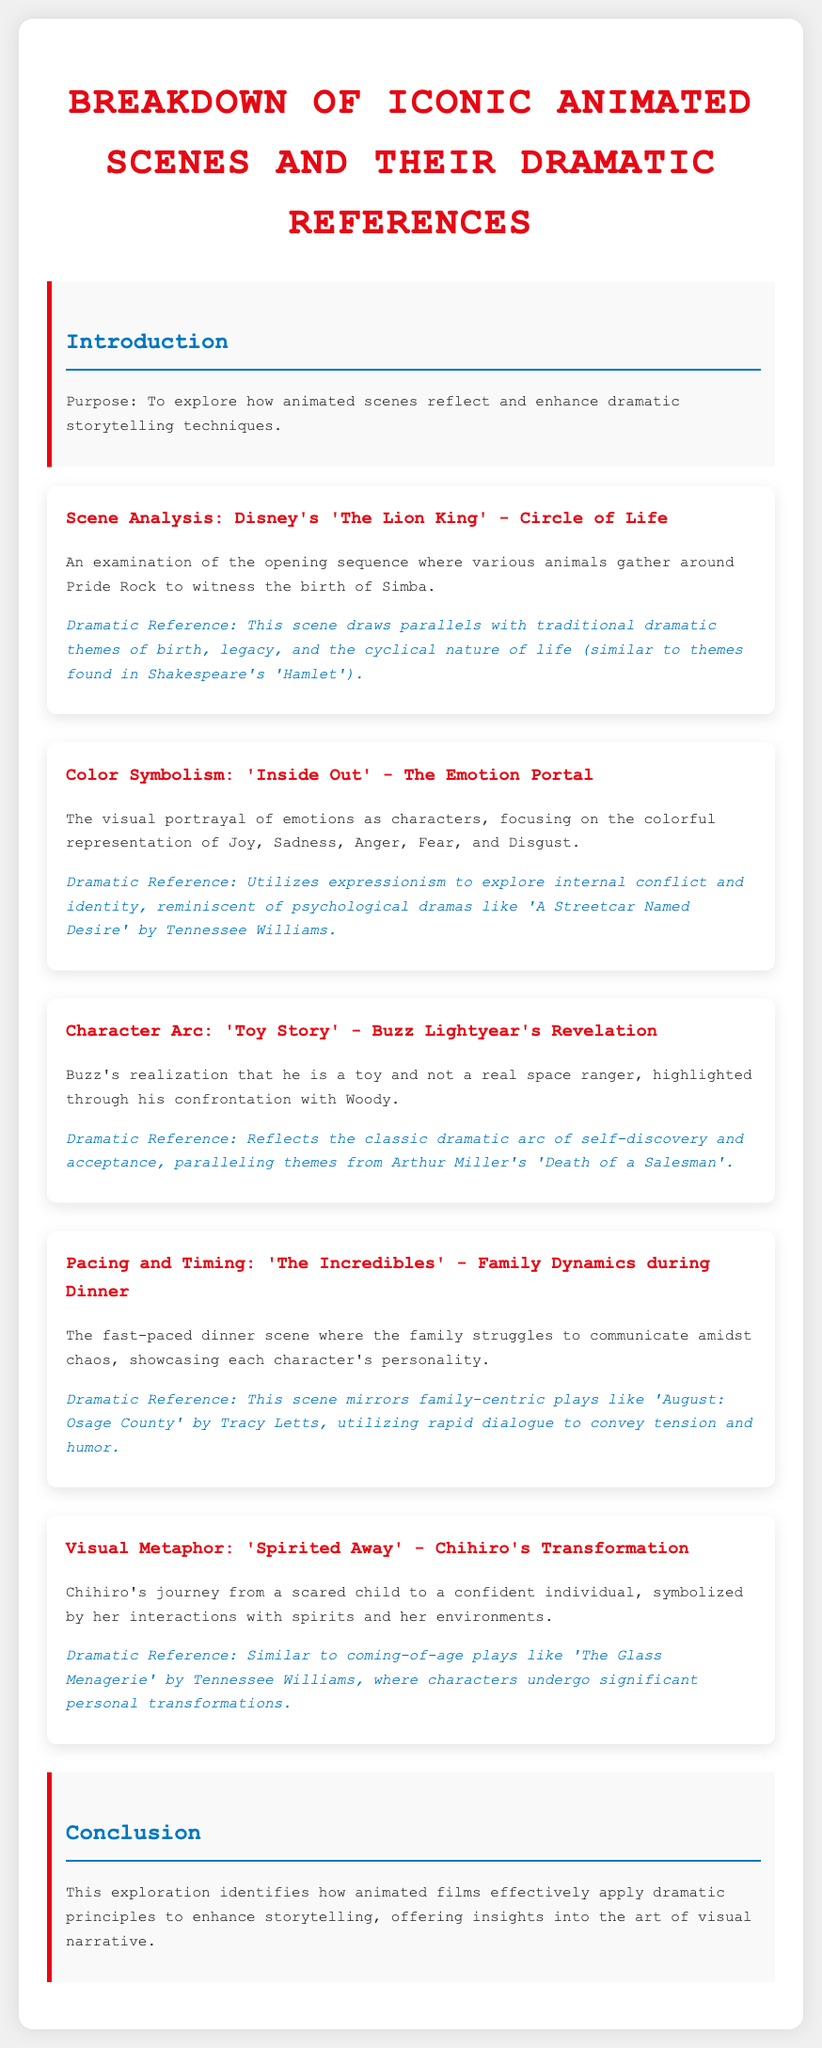What is the title of the document? The title of the document is prominently displayed at the top and serves as the main focus.
Answer: Breakdown of Iconic Animated Scenes and Their Dramatic References What is analyzed in the scene titled "Circle of Life"? The specific scene analysis discusses a significant moment from the film and highlights its thematic elements.
Answer: The opening sequence where various animals gather around Pride Rock to witness the birth of Simba What dramatic reference is associated with "Inside Out"? The dramatic reference connects the visual portrayal of emotions to a specific work in drama, indicating deeper themes.
Answer: Psychological dramas like 'A Streetcar Named Desire' by Tennessee Williams Which animated film features Buzz Lightyear's revelation? The document lists various animated films and describes character arcs or scenes from them, pinpointing Buzz's significant moment.
Answer: Toy Story In which scene does the family struggle to communicate? The descriptions of animated scenes reflect elements and characteristics central to family dynamics in the context of the animated narrative.
Answer: The fast-paced dinner scene in 'The Incredibles' Which playwright's work parallels Chihiro's transformation in "Spirited Away"? The reference to an author's work in the context of character development connects dramatic literature to animation effectively.
Answer: Tennessee Williams 